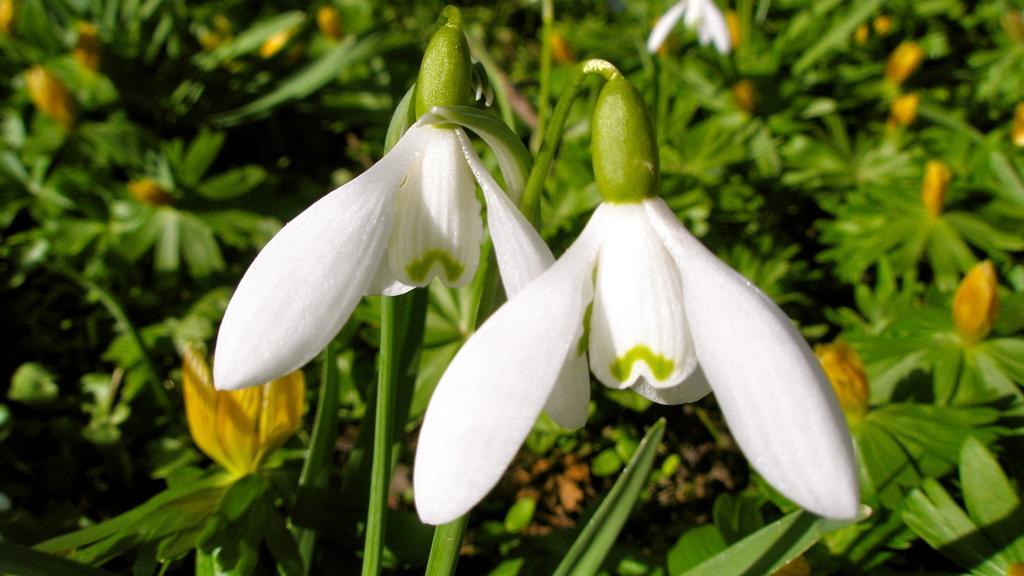How would you summarize this image in a sentence or two? In front of the picture, we see flowers in white color. Behind that, we see plants which have flowers and these flowers are in yellow color. This picture is blurred in the background and it is green in color. 